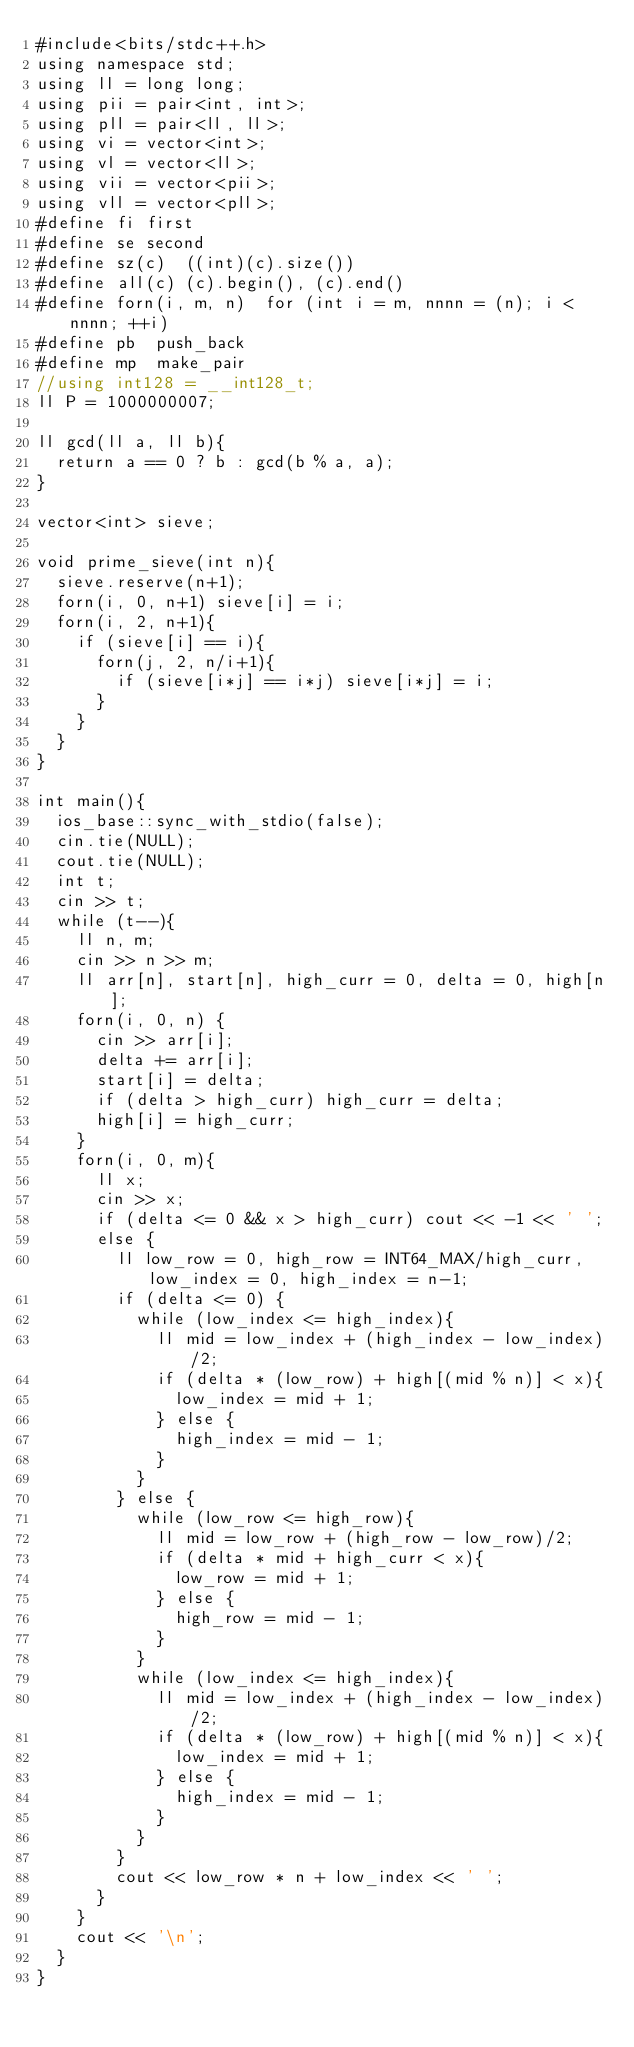<code> <loc_0><loc_0><loc_500><loc_500><_C++_>#include<bits/stdc++.h>
using namespace std;
using ll = long long;
using pii = pair<int, int>;
using pll = pair<ll, ll>;
using vi = vector<int>;
using vl = vector<ll>;
using vii = vector<pii>;
using vll = vector<pll>;
#define fi first
#define se second
#define sz(c)  ((int)(c).size())
#define all(c) (c).begin(), (c).end()
#define forn(i, m, n)  for (int i = m, nnnn = (n); i < nnnn; ++i)
#define pb  push_back
#define mp  make_pair
//using int128 = __int128_t;
ll P = 1000000007;

ll gcd(ll a, ll b){
	return a == 0 ? b : gcd(b % a, a);
}

vector<int> sieve;

void prime_sieve(int n){
	sieve.reserve(n+1);
	forn(i, 0, n+1) sieve[i] = i;
	forn(i, 2, n+1){
		if (sieve[i] == i){
			forn(j, 2, n/i+1){
				if (sieve[i*j] == i*j) sieve[i*j] = i;
			}
		}
	}
}

int main(){
	ios_base::sync_with_stdio(false);
	cin.tie(NULL);
	cout.tie(NULL);
	int t;
	cin >> t;
	while (t--){
		ll n, m;
		cin >> n >> m;
		ll arr[n], start[n], high_curr = 0, delta = 0, high[n];
		forn(i, 0, n) {
			cin >> arr[i];
			delta += arr[i];
			start[i] = delta;
			if (delta > high_curr) high_curr = delta;
			high[i] = high_curr;
		}
		forn(i, 0, m){
			ll x;
			cin >> x;
			if (delta <= 0 && x > high_curr) cout << -1 << ' ';
			else {
				ll low_row = 0, high_row = INT64_MAX/high_curr, low_index = 0, high_index = n-1;
				if (delta <= 0) {
					while (low_index <= high_index){
						ll mid = low_index + (high_index - low_index)/2;
						if (delta * (low_row) + high[(mid % n)] < x){
							low_index = mid + 1;
						} else {
							high_index = mid - 1;
						}
					}
				} else {
					while (low_row <= high_row){
						ll mid = low_row + (high_row - low_row)/2;
						if (delta * mid + high_curr < x){
							low_row = mid + 1;
						} else {
							high_row = mid - 1;
						}
					}
					while (low_index <= high_index){
						ll mid = low_index + (high_index - low_index)/2;
						if (delta * (low_row) + high[(mid % n)] < x){
							low_index = mid + 1;
						} else {
							high_index = mid - 1;
						}
					}
				}
				cout << low_row * n + low_index << ' ';
			}
		}
		cout << '\n';
	}
}</code> 